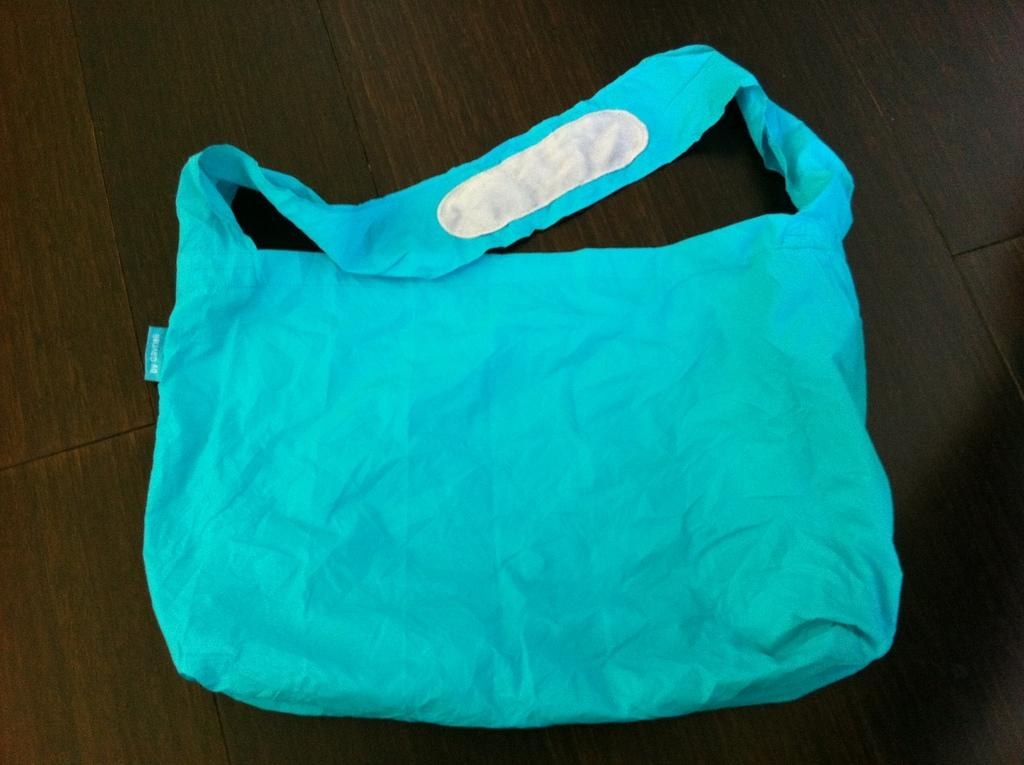What type of bag is visible in the image? There is a blue color cloth bag in the image. Where is the cloth bag located? The cloth bag is placed on a wooden platform. What type of protest is happening near the cloth bag in the image? There is no protest visible in the image; it only features a blue color cloth bag on a wooden platform. 